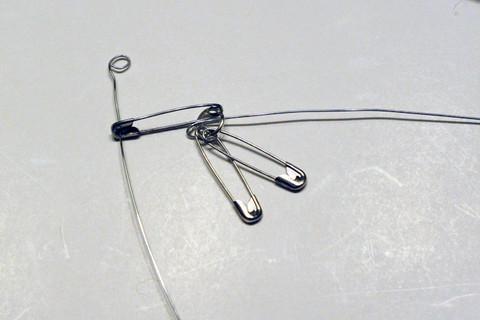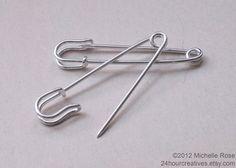The first image is the image on the left, the second image is the image on the right. For the images displayed, is the sentence "An image contains exactly two safety pins, displayed one above the other, and not overlapping." factually correct? Answer yes or no. No. The first image is the image on the left, the second image is the image on the right. Evaluate the accuracy of this statement regarding the images: "The two pins in the image on the left are not touching each other.". Is it true? Answer yes or no. No. 